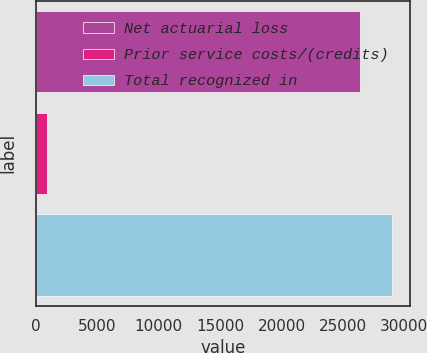<chart> <loc_0><loc_0><loc_500><loc_500><bar_chart><fcel>Net actuarial loss<fcel>Prior service costs/(credits)<fcel>Total recognized in<nl><fcel>26387<fcel>904<fcel>29025.7<nl></chart> 